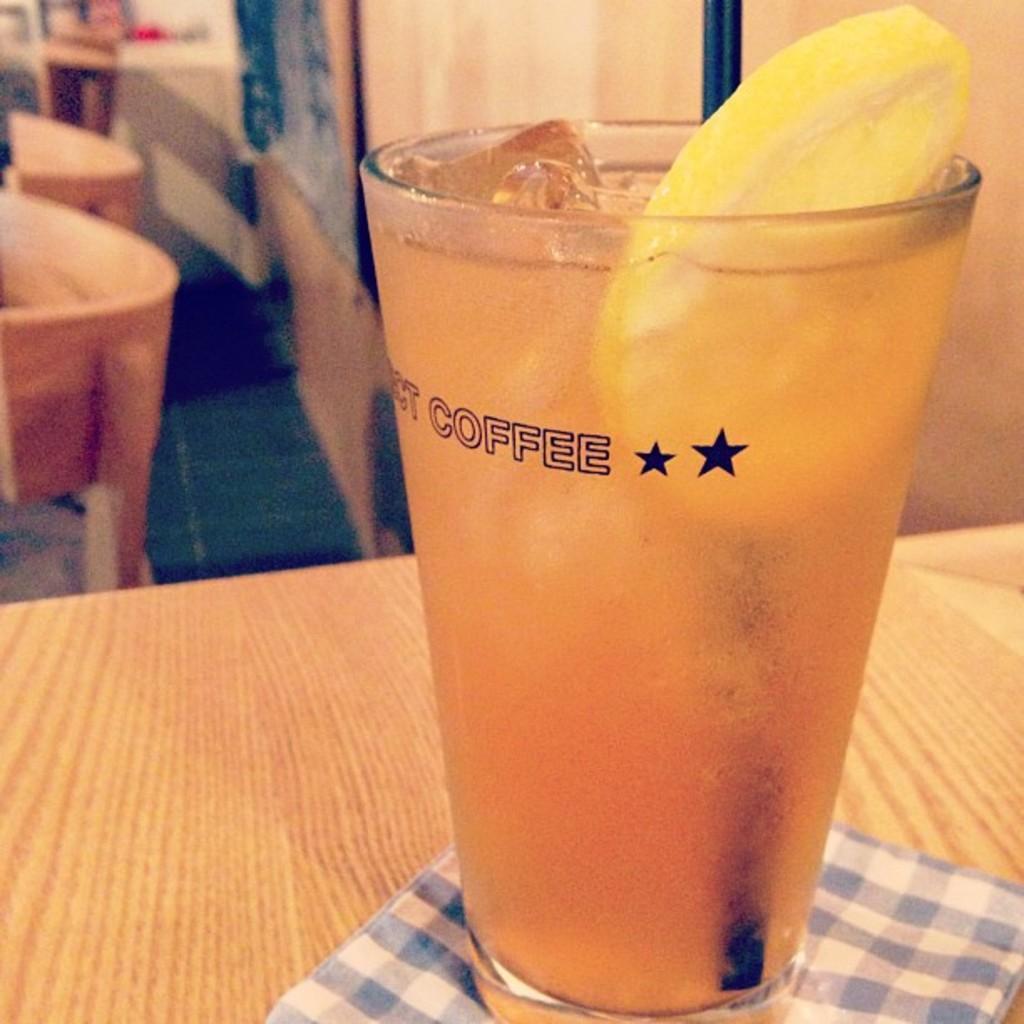Can you describe this image briefly? There is a table which has a glass of shake on it. 